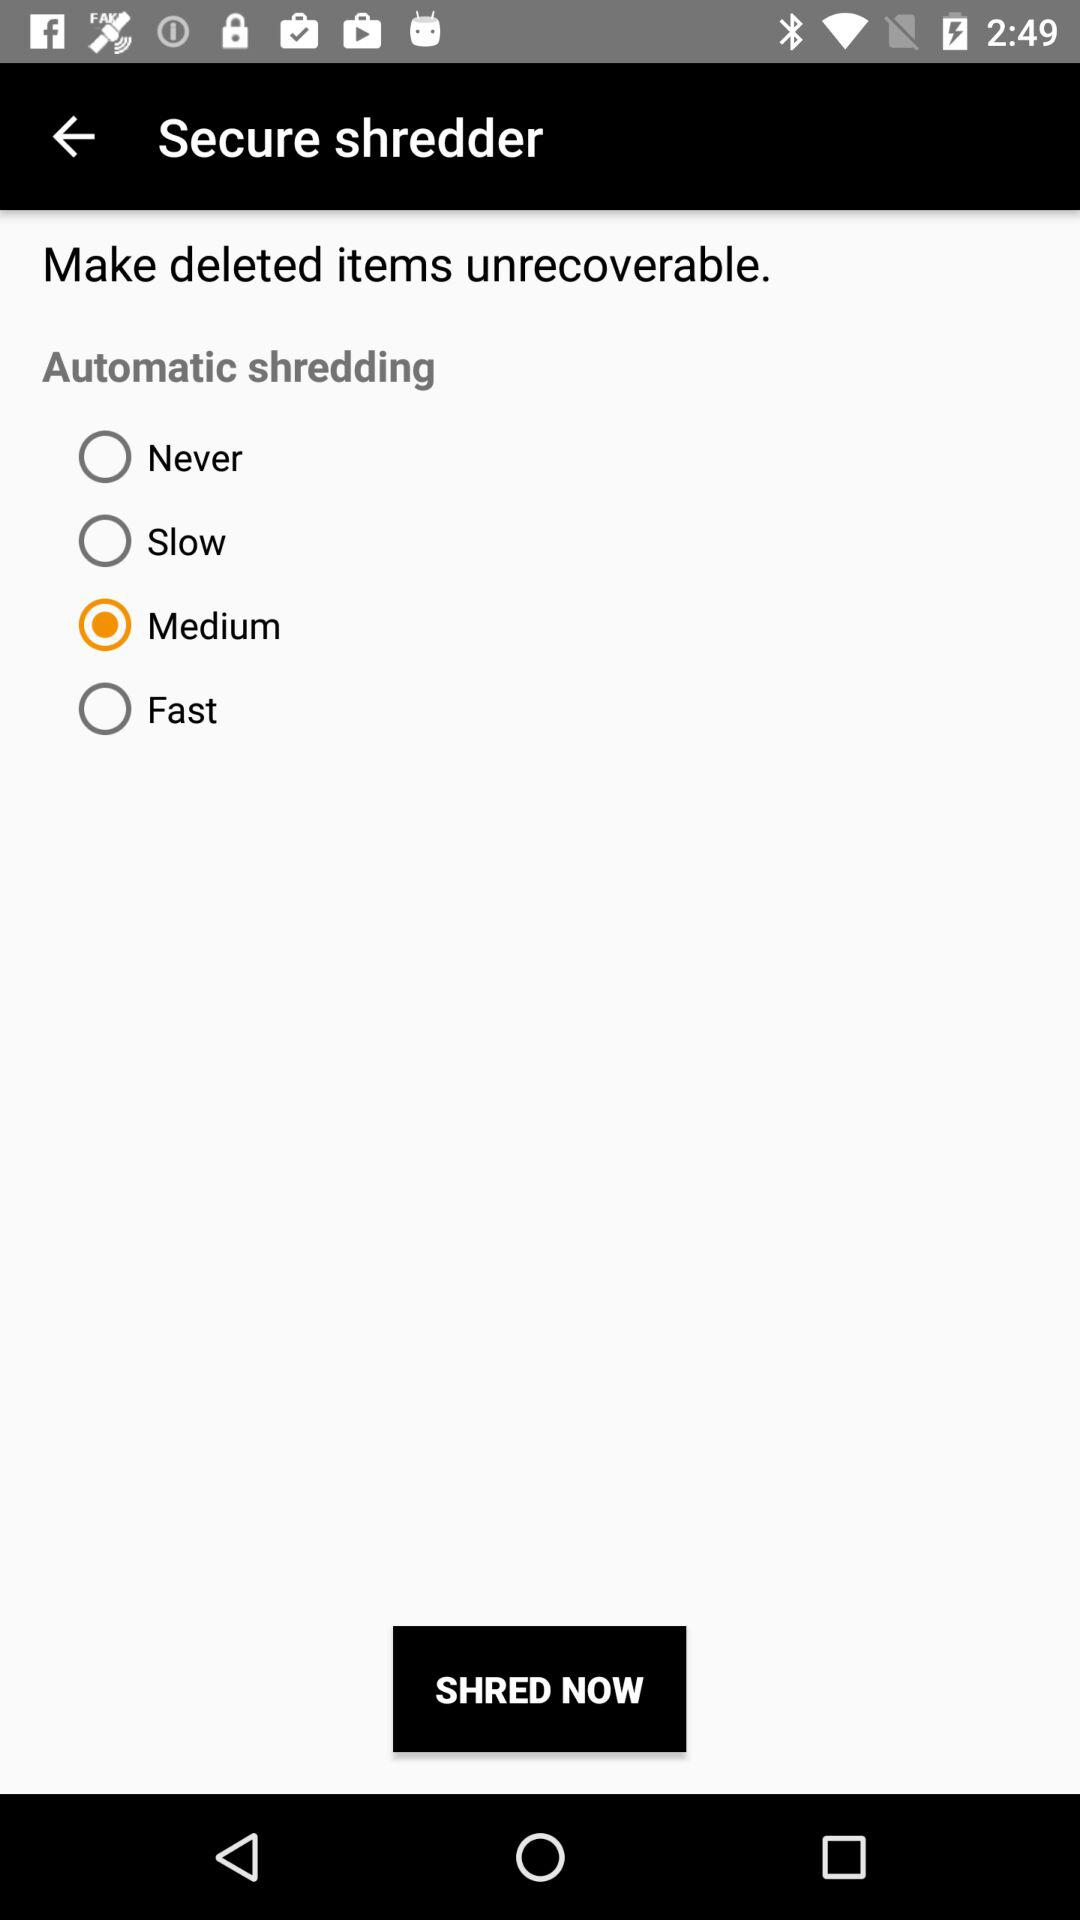How many items can be shredded?
When the provided information is insufficient, respond with <no answer>. <no answer> 